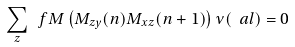<formula> <loc_0><loc_0><loc_500><loc_500>\sum _ { z } \ f M \left ( M _ { z y } ( n ) M _ { x z } ( n + 1 ) \right ) \nu ( \ a l ) = 0</formula> 